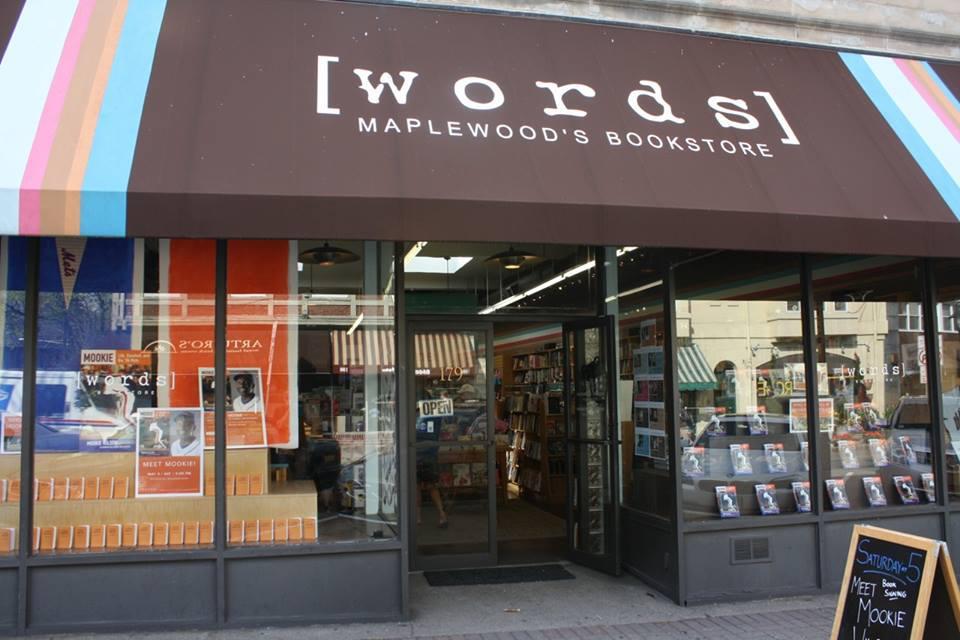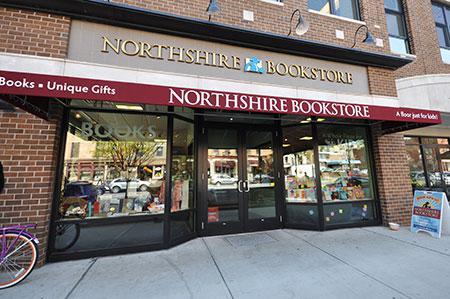The first image is the image on the left, the second image is the image on the right. For the images displayed, is the sentence "In one image, an awning with advertising extends over the front of a bookstore." factually correct? Answer yes or no. Yes. 